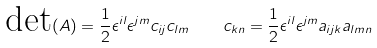Convert formula to latex. <formula><loc_0><loc_0><loc_500><loc_500>\text {det} ( A ) = \frac { 1 } { 2 } \epsilon ^ { i l } \epsilon ^ { j m } c _ { i j } c _ { l m } \quad c _ { k n } = \frac { 1 } { 2 } \epsilon ^ { i l } \epsilon ^ { j m } a _ { i j k } a _ { l m n }</formula> 